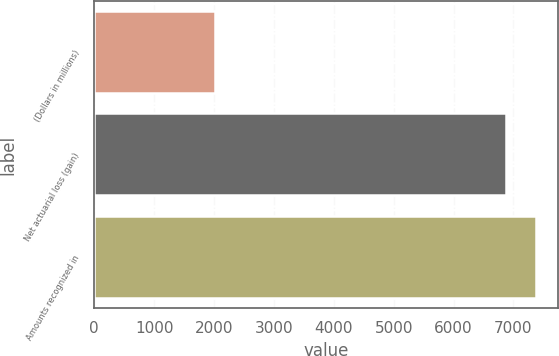<chart> <loc_0><loc_0><loc_500><loc_500><bar_chart><fcel>(Dollars in millions)<fcel>Net actuarial loss (gain)<fcel>Amounts recognized in<nl><fcel>2011<fcel>6881<fcel>7380.8<nl></chart> 